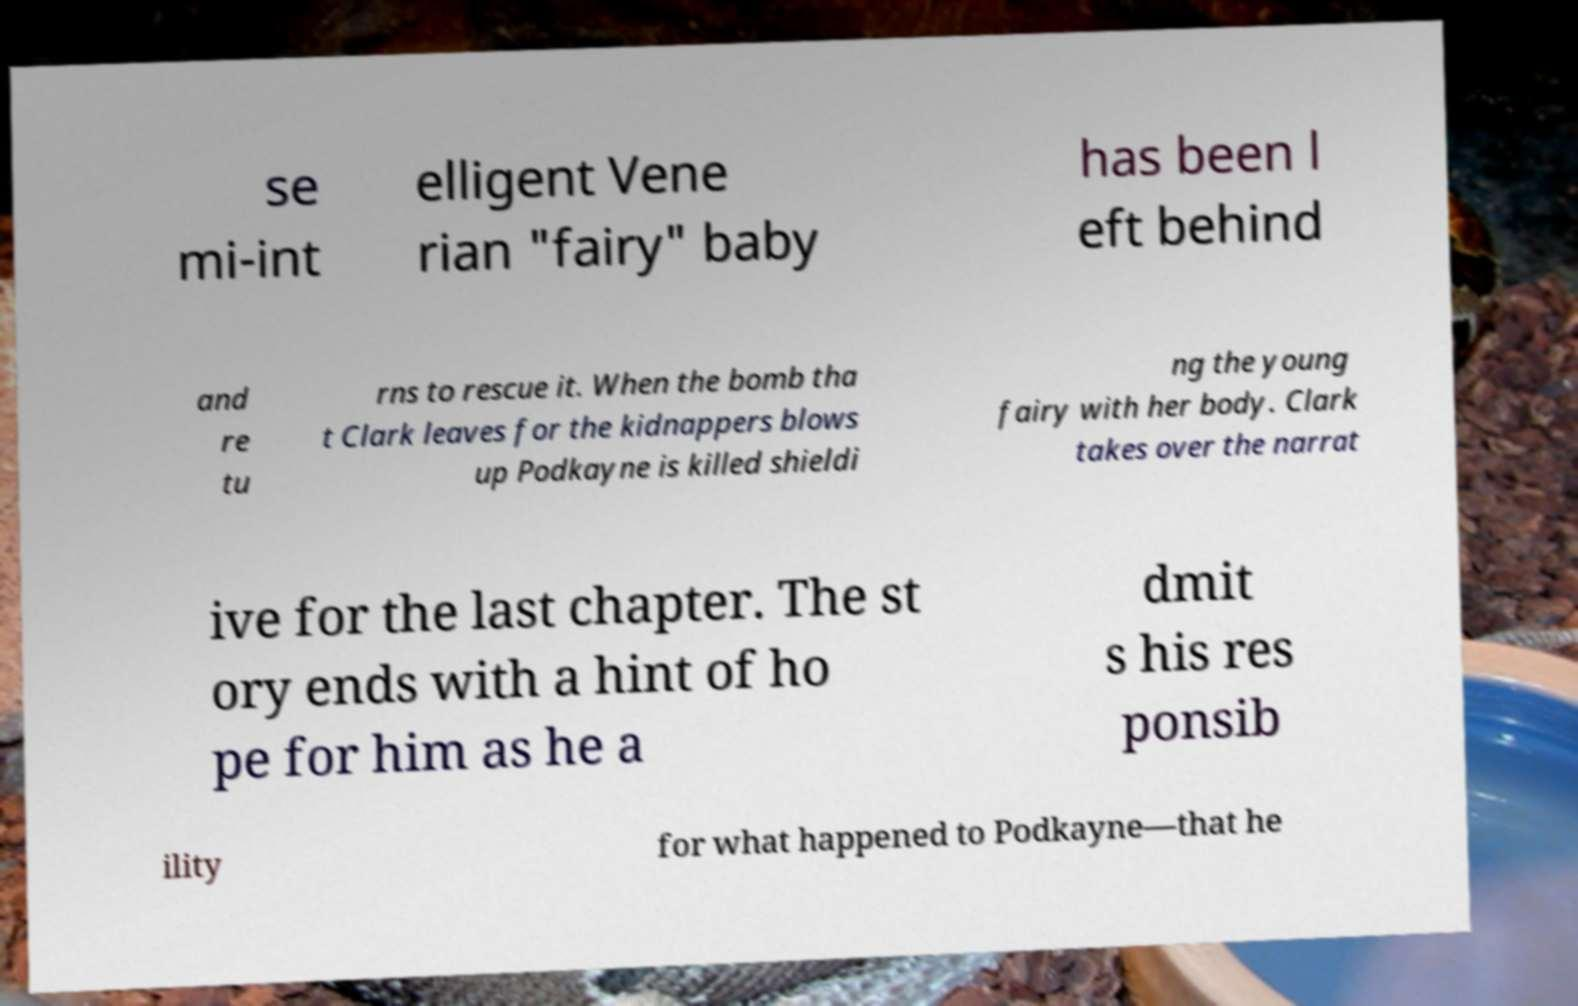What messages or text are displayed in this image? I need them in a readable, typed format. se mi-int elligent Vene rian "fairy" baby has been l eft behind and re tu rns to rescue it. When the bomb tha t Clark leaves for the kidnappers blows up Podkayne is killed shieldi ng the young fairy with her body. Clark takes over the narrat ive for the last chapter. The st ory ends with a hint of ho pe for him as he a dmit s his res ponsib ility for what happened to Podkayne—that he 